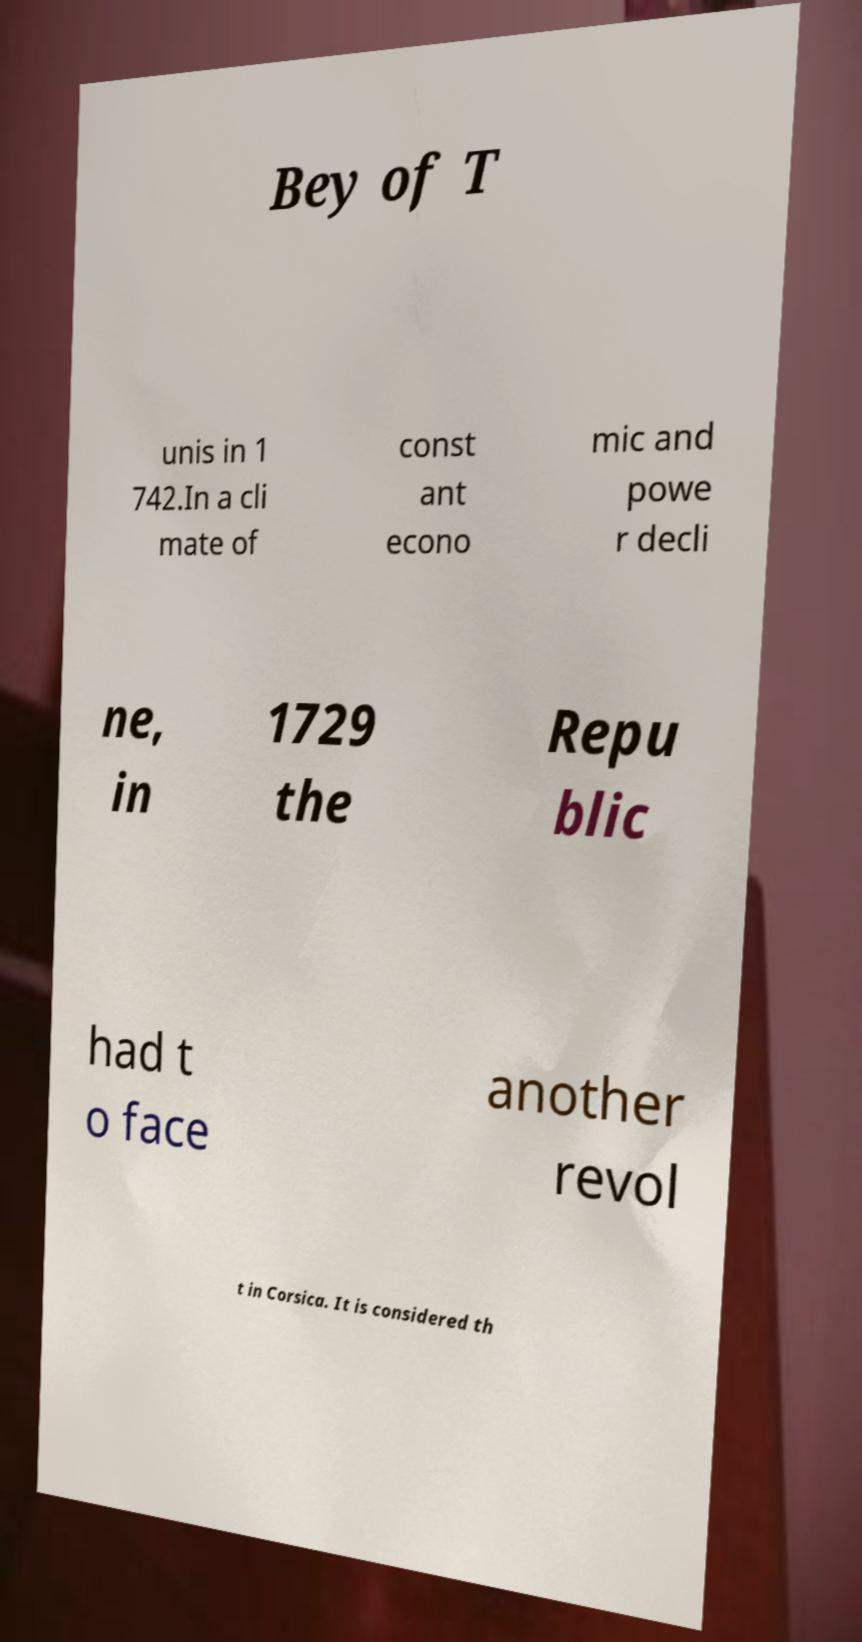What messages or text are displayed in this image? I need them in a readable, typed format. Bey of T unis in 1 742.In a cli mate of const ant econo mic and powe r decli ne, in 1729 the Repu blic had t o face another revol t in Corsica. It is considered th 